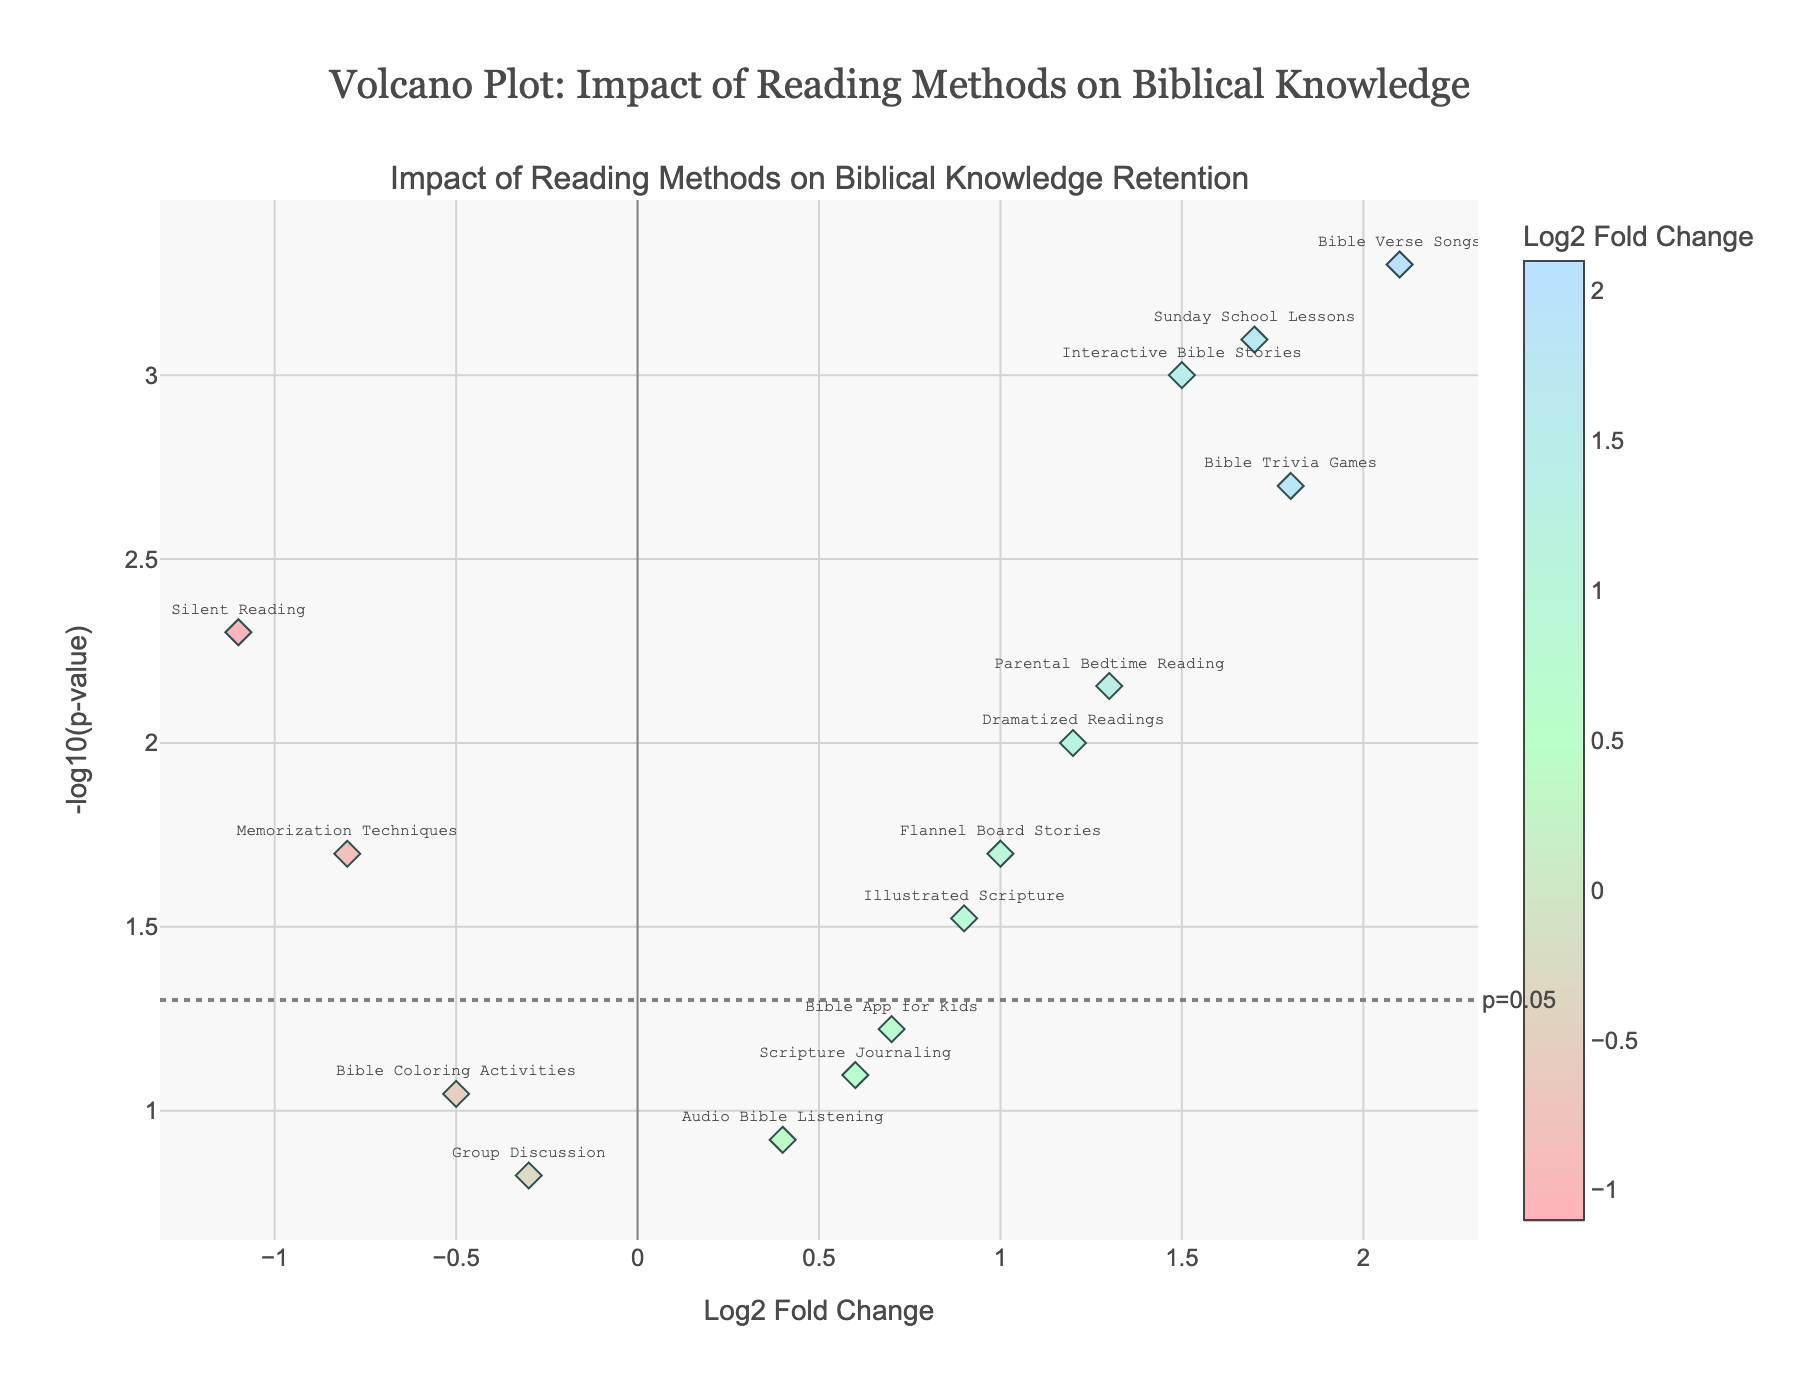How many data points are on the plot? Count the number of markers (diamonds) on the plot. Each marker represents one reading method
Answer: 15 Which reading method has the highest Log2 Fold Change? Look for the marker furthest to the right on the x-axis. The hover text indicates that "Bible Verse Songs" has a Log2 Fold Change of 2.1
Answer: Bible Verse Songs What is the significance threshold p-value indicated on the plot? Identify the horizontal line marked with a label. The label shows "p=0.05"
Answer: 0.05 Is "Interactive Bible Stories" statistically significant at p < 0.05? Check the y-axis value for "Interactive Bible Stories". It should be above the significance threshold line
Answer: Yes Which methods show a negative impact on biblical knowledge retention? Identify markers that fall to the left of the y-axis (negative Log2 Fold Change). "Memorization Techniques," "Group Discussion," "Silent Reading," and "Bible Coloring Activities" have negative Log2 Fold Change values
Answer: Memorization Techniques, Group Discussion, Silent Reading, Bible Coloring Activities How many reading methods have a p-value less than 0.01? Look for markers that are above the -log10(0.01) line on the y-axis. These methods are "Interactive Bible Stories," "Bible Verse Songs," "Dramatized Readings," "Bible Trivia Games," "Silent Reading," "Parental Bedtime Reading," and "Sunday School Lessons"
Answer: 7 Which two methods have the closest Log2 Fold Change values? Compare the x-axis values. "Scripture Journaling" and "Bible App for Kids" are very close, both with Log2 Fold Changes of 0.6 and 0.7, respectively
Answer: Scripture Journaling and Bible App for Kids What is the Log2 Fold Change for "Bible Trivia Games"? Look at the x-axis value for "Bible Trivia Games." The hover text shows a Log2 Fold Change of 1.8
Answer: 1.8 Which method has a Log2 Fold Change less than 1 but a p-value less than 0.05? Look for markers with x-values less than 1 and y-values above the significance threshold line. "Flannel Board Stories" has a Log2 Fold Change of 1.0, so it doesn't meet the criteria. "Dramatized Readings" has 1.2, so the correct answer is "Interactive Bible Stories" (1.5)
Answer: Interactive Bible Stories Which method shows the smallest impact on biblical knowledge retention, whether positive or negative? Identify the marker closest to the y-axis (Log2 Fold Change close to 0). "Group Discussion" has a Log2 Fold Change of -0.3
Answer: Group Discussion 